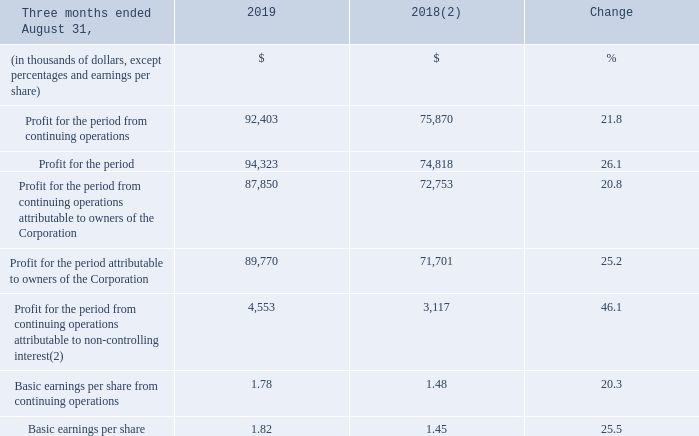(1) Fiscal 2018 was restated to comply with IFRS 15 and to reflect a change in accounting policy as well as to reclassify results from Cogeco Peer 1 as discontinued operations. For further details, please consult the "Accounting policies" and "Discontinued operations" sections.
(2) The non-controlling interest represents a participation of 21% in Atlantic Broadband's results by Caisse de dépot et placement du Québec ("CDPQ"), effective since the MetroCast acquisition on January 4, 2018.
Fiscal 2019 fourth-quarter profit for the period from continuing operations and profit for the period from continuing operations attributable to owners of the Corporation increased by 21.8% and 20.8%, respectively, as a result of: • higher adjusted EBITDA; and • the decrease in financial expense.
Fiscal 2019 fourth-quarter profit for the period and profit for the period attributable to owners of the Corporation increased by 26.1% and 25.2%, respectively, mainly due to a profit for the period from discontinued operations of $1.9 million due to working capital adjustments during the fourth quarter related to the sale of Cogeco Peer 1 compared to a loss for the period from discontinued operations of $1.1 million for the comparable period of the prior year in addition to the elements mentioned above.
How much was the Fiscal 2019 fourth-quarter profit for the period increase from continuing operations? 21.8%. How much was the profit increase for the period from continuing operations attributable to owners of the Corporation? 20.8%. What led to increase in the Fiscal 2019 fourth-quarter profit for the period and profit for the period attributable to owners of the Corporation? Mainly due to a profit for the period from discontinued operations of $1.9 million due to working capital adjustments during the fourth quarter related to the sale of cogeco peer 1 compared to a loss for the period from discontinued operations of $1.1 million for the comparable period of the prior year in addition to the elements mentioned above. What is the increase/ (decrease) in Profit for the period from continuing operations from 2018 to 2019?
Answer scale should be: thousand. 92,403-75,870
Answer: 16533. What is the increase/ (decrease) in Profit for the period from continuing operations attributable to owners of the Corporation from 2018 to 2019?
Answer scale should be: thousand. 87,850-72,753
Answer: 15097. What is the increase/ (decrease) in Profit for the period attributable to owners of the Corporation from 2018 to 2019?
Answer scale should be: thousand. 89,770-71,701
Answer: 18069. 